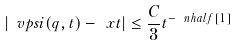<formula> <loc_0><loc_0><loc_500><loc_500>\left | \ v p s i ( q , t ) - \ x t \right | \leq \frac { C } { 3 } t ^ { - \ n h a l f [ 1 ] }</formula> 